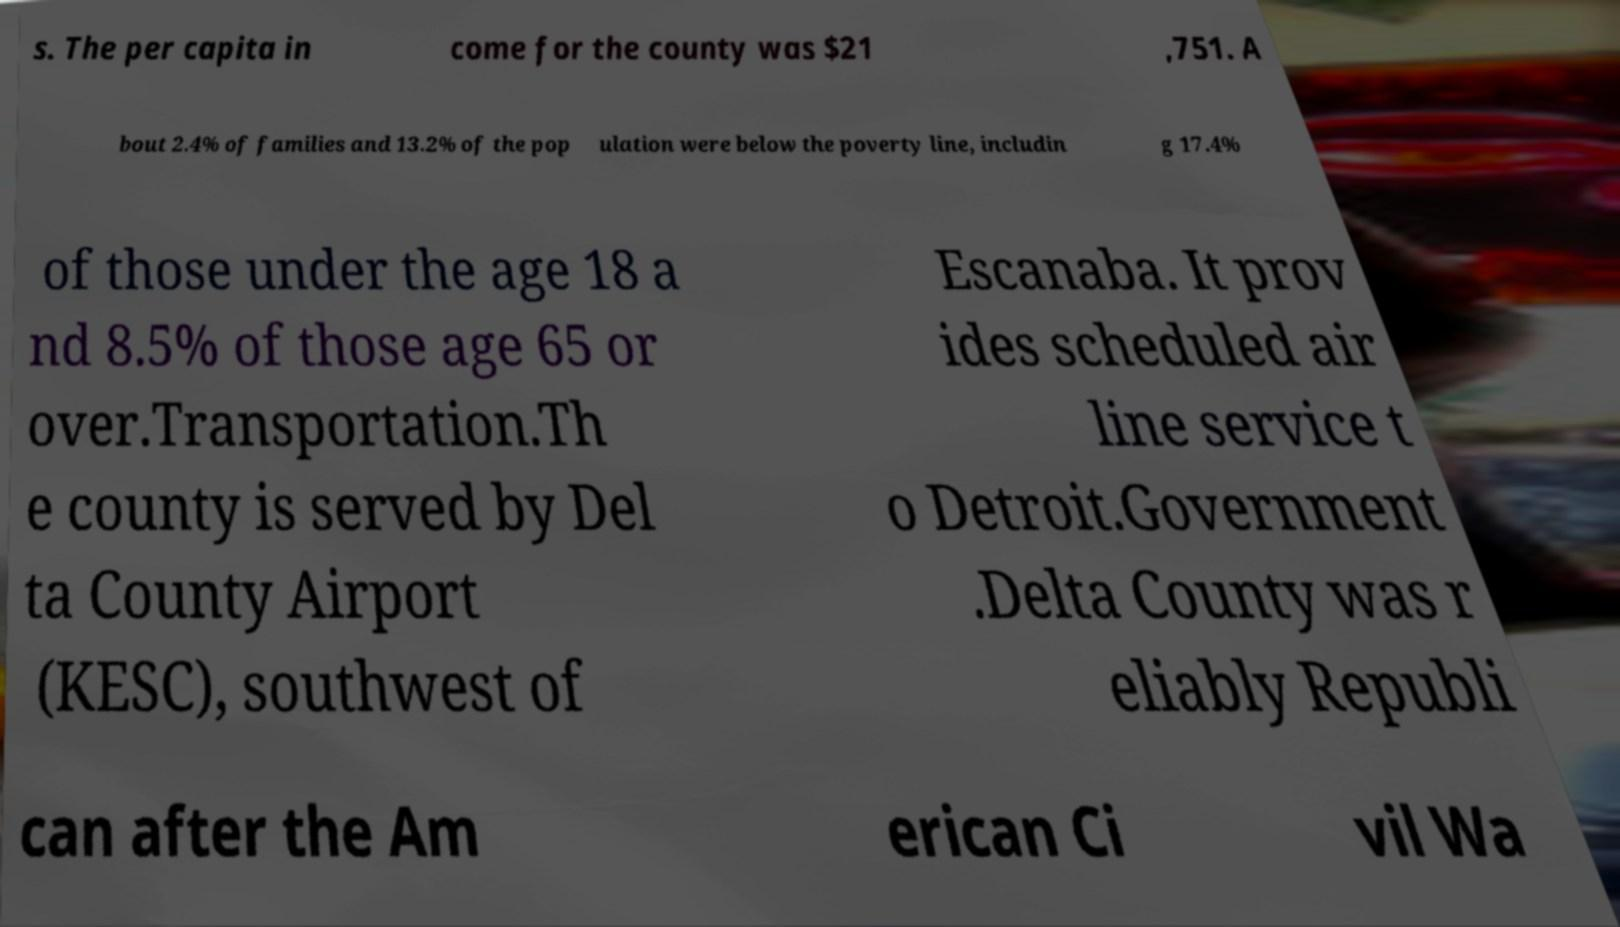I need the written content from this picture converted into text. Can you do that? s. The per capita in come for the county was $21 ,751. A bout 2.4% of families and 13.2% of the pop ulation were below the poverty line, includin g 17.4% of those under the age 18 a nd 8.5% of those age 65 or over.Transportation.Th e county is served by Del ta County Airport (KESC), southwest of Escanaba. It prov ides scheduled air line service t o Detroit.Government .Delta County was r eliably Republi can after the Am erican Ci vil Wa 